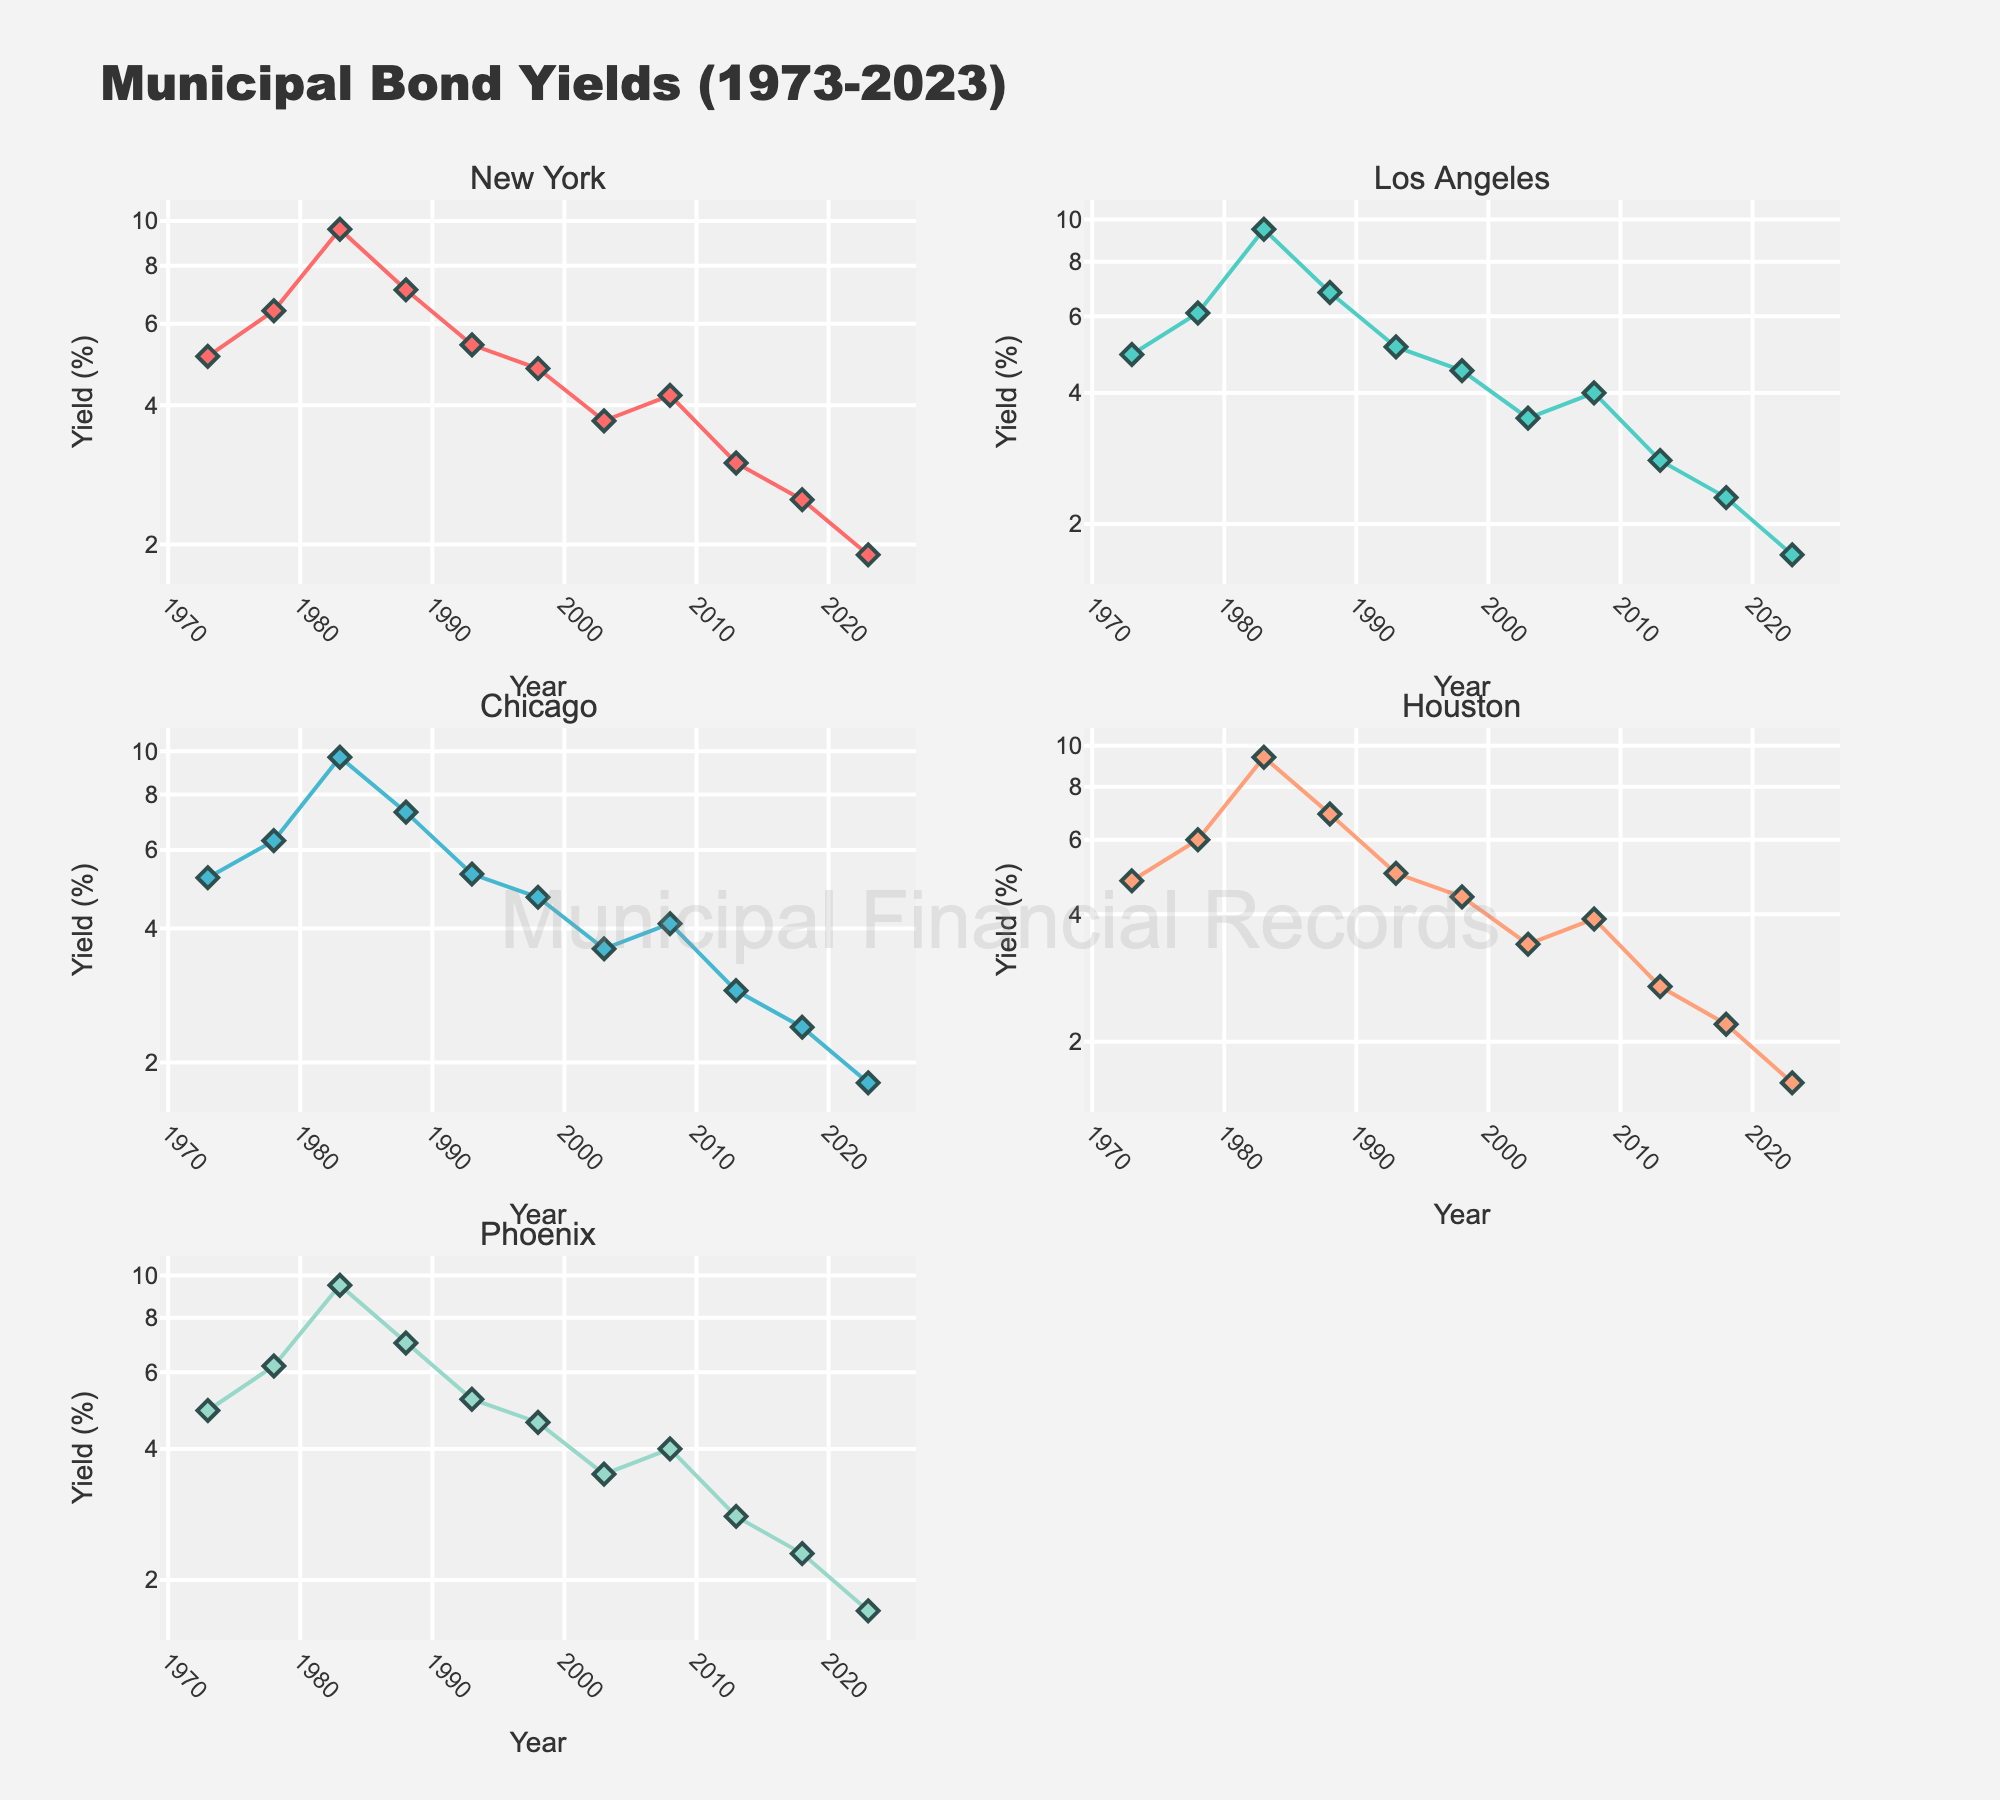What's the title of the plot? The title is located at the top center of the figure. It reads "Municipal Bond Yields (1973-2023)"
Answer: Municipal Bond Yields (1973-2023) What is the y-axis type used in the subplots? Observing the y-axes for all subplots shows they use a log scale as indicated by the unevenly spaced tick marks.
Answer: Log scale Which city had the highest bond yield in 1983? By looking at the year 1983 across all subplots, Chicago shows the highest yield, above 9.6.
Answer: Chicago How does the bond yield for Phoenix in 2023 compare to that in 1973? Comparing the 2023 and 1973 data points in Phoenix's subplot shows a decrease from around 4.9 in 1973 to 1.7 in 2023.
Answer: It decreased Which city showed the most stable yield from 1973 to 2023? "Stability" means less variance. By visually scanning the plots, Los Angeles appears to have the most stable bond yield, showing less abrupt changes overall.
Answer: Los Angeles What's the average bond yield for Houston in 1993 and 1998? Adding yields for Houston in 1993 (5.0) and 1998 (4.4) and then dividing by 2 shows the average. Calculation: (5.0 + 4.4) / 2 = 4.7
Answer: 4.7 Which year had the lowest yield for New York? By identifying the lowest point in the New York subplot, it can be seen that 2023 had the lowest yield of about 1.9.
Answer: 2023 What is the difference between the highest and lowest bond yields for Chicago? Highest is in 1983 (9.7), lowest in 2023 (1.8). Calculation: 9.7 - 1.8 = 7.9
Answer: 7.9 Which city had the steepest drop in yield over any five-year period? For steep drops, look for the most significant vertical decrease within any subplot. Chicago from 1983 (9.7) to 1988 (7.3) stands out as the largest decrease over five years: 9.7 - 7.3 = 2.4
Answer: Chicago What is the pattern of bond yields for all cities during the 2008 financial crisis? Observing yields around 2008 helps identify trends. All cities show a slight increase around 2008 followed by a decrease afterward, with Phoenix showing this most visibly.
Answer: Slight increase followed by decrease 